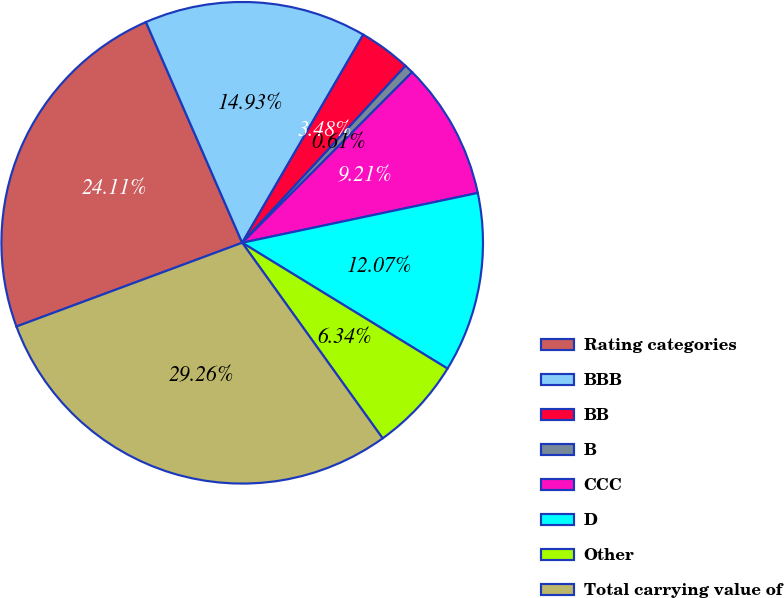Convert chart to OTSL. <chart><loc_0><loc_0><loc_500><loc_500><pie_chart><fcel>Rating categories<fcel>BBB<fcel>BB<fcel>B<fcel>CCC<fcel>D<fcel>Other<fcel>Total carrying value of<nl><fcel>24.11%<fcel>14.93%<fcel>3.48%<fcel>0.61%<fcel>9.21%<fcel>12.07%<fcel>6.34%<fcel>29.26%<nl></chart> 